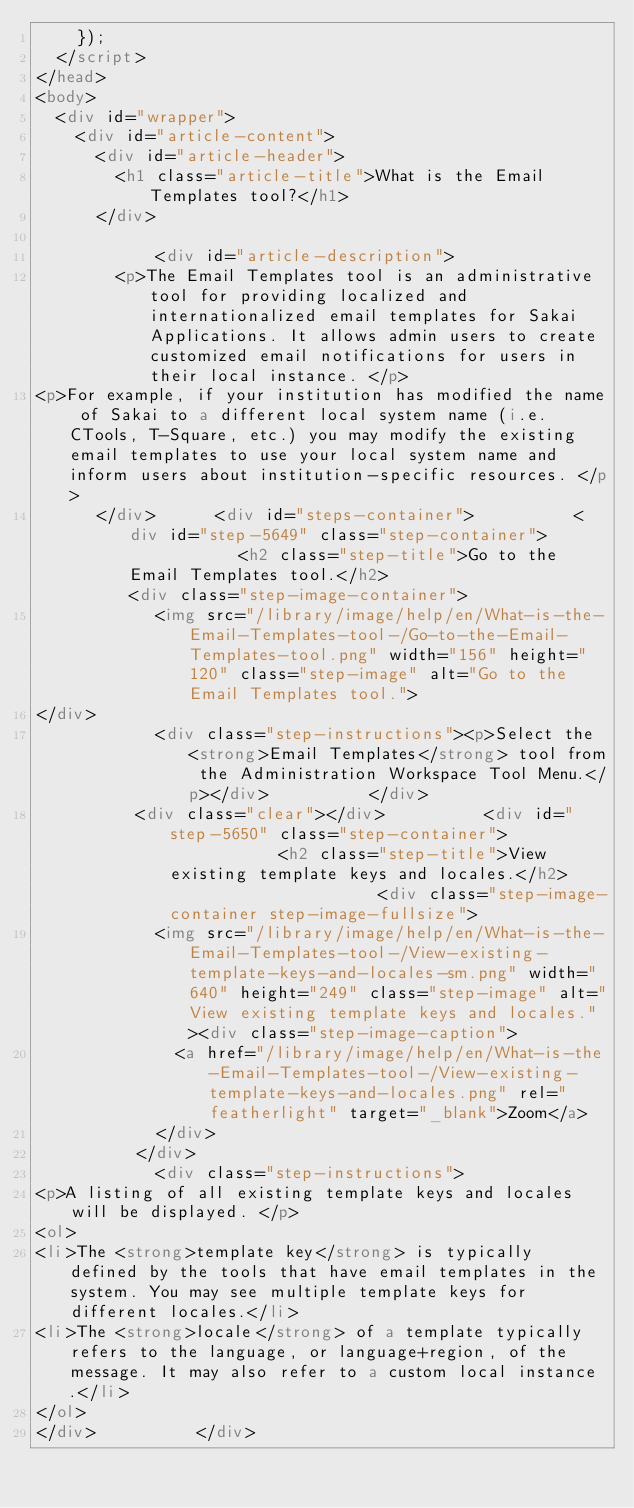Convert code to text. <code><loc_0><loc_0><loc_500><loc_500><_HTML_>    }); 	
  </script>
</head>
<body>
  <div id="wrapper">
    <div id="article-content">
      <div id="article-header">
        <h1 class="article-title">What is the Email Templates tool?</h1>
      </div>

            <div id="article-description">
        <p>The Email Templates tool is an administrative tool for providing localized and internationalized email templates for Sakai Applications. It allows admin users to create customized email notifications for users in their local instance. </p>
<p>For example, if your institution has modified the name of Sakai to a different local system name (i.e. CTools, T-Square, etc.) you may modify the existing email templates to use your local system name and inform users about institution-specific resources. </p>
      </div>      <div id="steps-container">          <div id="step-5649" class="step-container">            <h2 class="step-title">Go to the Email Templates tool.</h2>                      <div class="step-image-container">
            <img src="/library/image/help/en/What-is-the-Email-Templates-tool-/Go-to-the-Email-Templates-tool.png" width="156" height="120" class="step-image" alt="Go to the Email Templates tool.">
</div>
            <div class="step-instructions"><p>Select the <strong>Email Templates</strong> tool from the Administration Workspace Tool Menu.</p></div>          </div>
          <div class="clear"></div>          <div id="step-5650" class="step-container">            <h2 class="step-title">View existing template keys and locales.</h2>                      <div class="step-image-container step-image-fullsize">
            <img src="/library/image/help/en/What-is-the-Email-Templates-tool-/View-existing-template-keys-and-locales-sm.png" width="640" height="249" class="step-image" alt="View existing template keys and locales."><div class="step-image-caption">
              <a href="/library/image/help/en/What-is-the-Email-Templates-tool-/View-existing-template-keys-and-locales.png" rel="featherlight" target="_blank">Zoom</a>
            </div>
          </div>
            <div class="step-instructions">
<p>A listing of all existing template keys and locales will be displayed. </p>
<ol>
<li>The <strong>template key</strong> is typically defined by the tools that have email templates in the system. You may see multiple template keys for different locales.</li>
<li>The <strong>locale</strong> of a template typically refers to the language, or language+region, of the message. It may also refer to a custom local instance.</li>
</ol>
</div>          </div></code> 